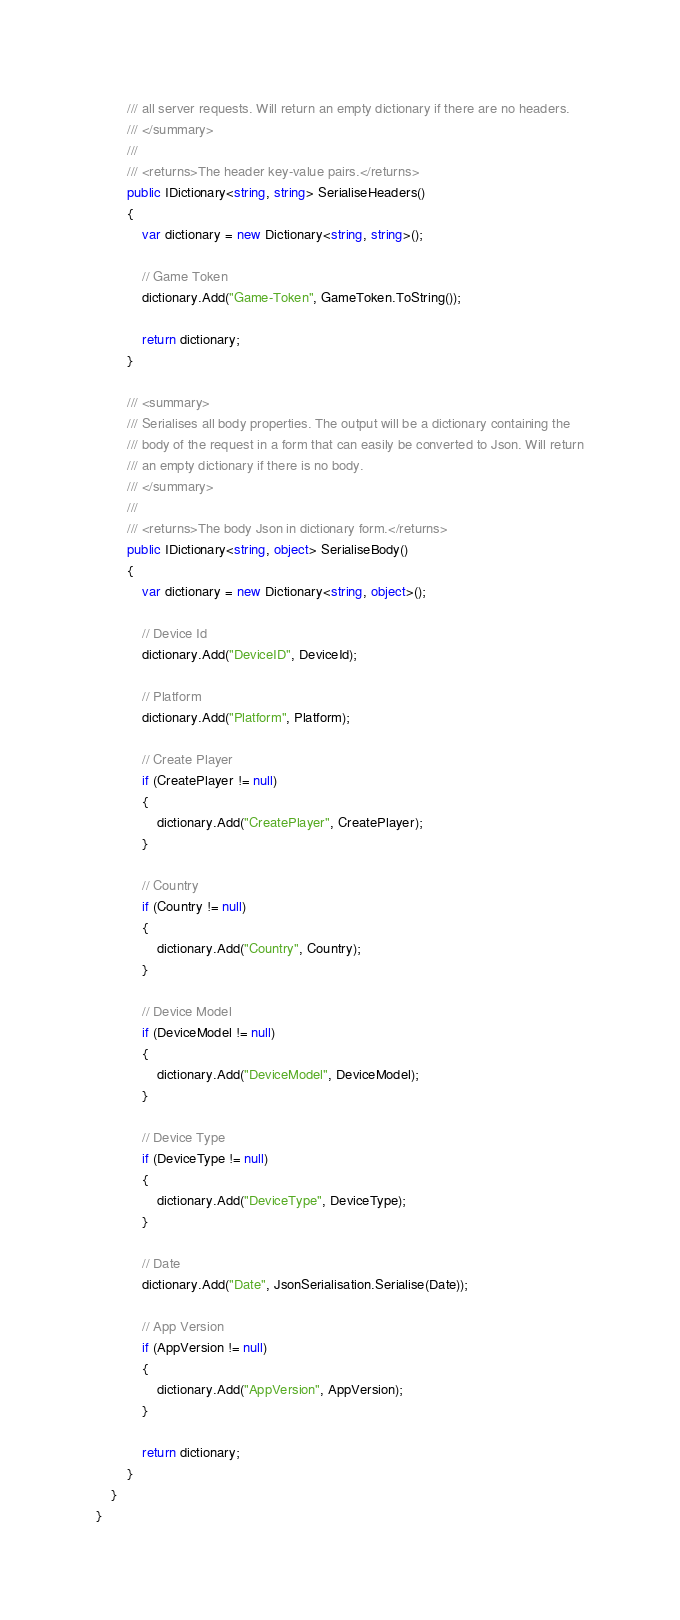Convert code to text. <code><loc_0><loc_0><loc_500><loc_500><_C#_>		/// all server requests. Will return an empty dictionary if there are no headers.
		/// </summary>
		///
		/// <returns>The header key-value pairs.</returns>
		public IDictionary<string, string> SerialiseHeaders()
		{
			var dictionary = new Dictionary<string, string>();
			
			// Game Token
			dictionary.Add("Game-Token", GameToken.ToString());
		
			return dictionary;
		}
		
		/// <summary>
		/// Serialises all body properties. The output will be a dictionary containing the 
		/// body of the request in a form that can easily be converted to Json. Will return
		/// an empty dictionary if there is no body.
		/// </summary>
		///
		/// <returns>The body Json in dictionary form.</returns>
		public IDictionary<string, object> SerialiseBody()
		{
            var dictionary = new Dictionary<string, object>();
			
			// Device Id
			dictionary.Add("DeviceID", DeviceId);
			
			// Platform
			dictionary.Add("Platform", Platform);
			
			// Create Player
			if (CreatePlayer != null)
			{
				dictionary.Add("CreatePlayer", CreatePlayer);
            }
			
			// Country
			if (Country != null)
			{
				dictionary.Add("Country", Country);
            }
			
			// Device Model
			if (DeviceModel != null)
			{
				dictionary.Add("DeviceModel", DeviceModel);
            }
			
			// Device Type
			if (DeviceType != null)
			{
				dictionary.Add("DeviceType", DeviceType);
            }
			
			// Date
            dictionary.Add("Date", JsonSerialisation.Serialise(Date));
			
			// App Version
			if (AppVersion != null)
			{
				dictionary.Add("AppVersion", AppVersion);
            }
	
			return dictionary;
		}
	}
}
</code> 